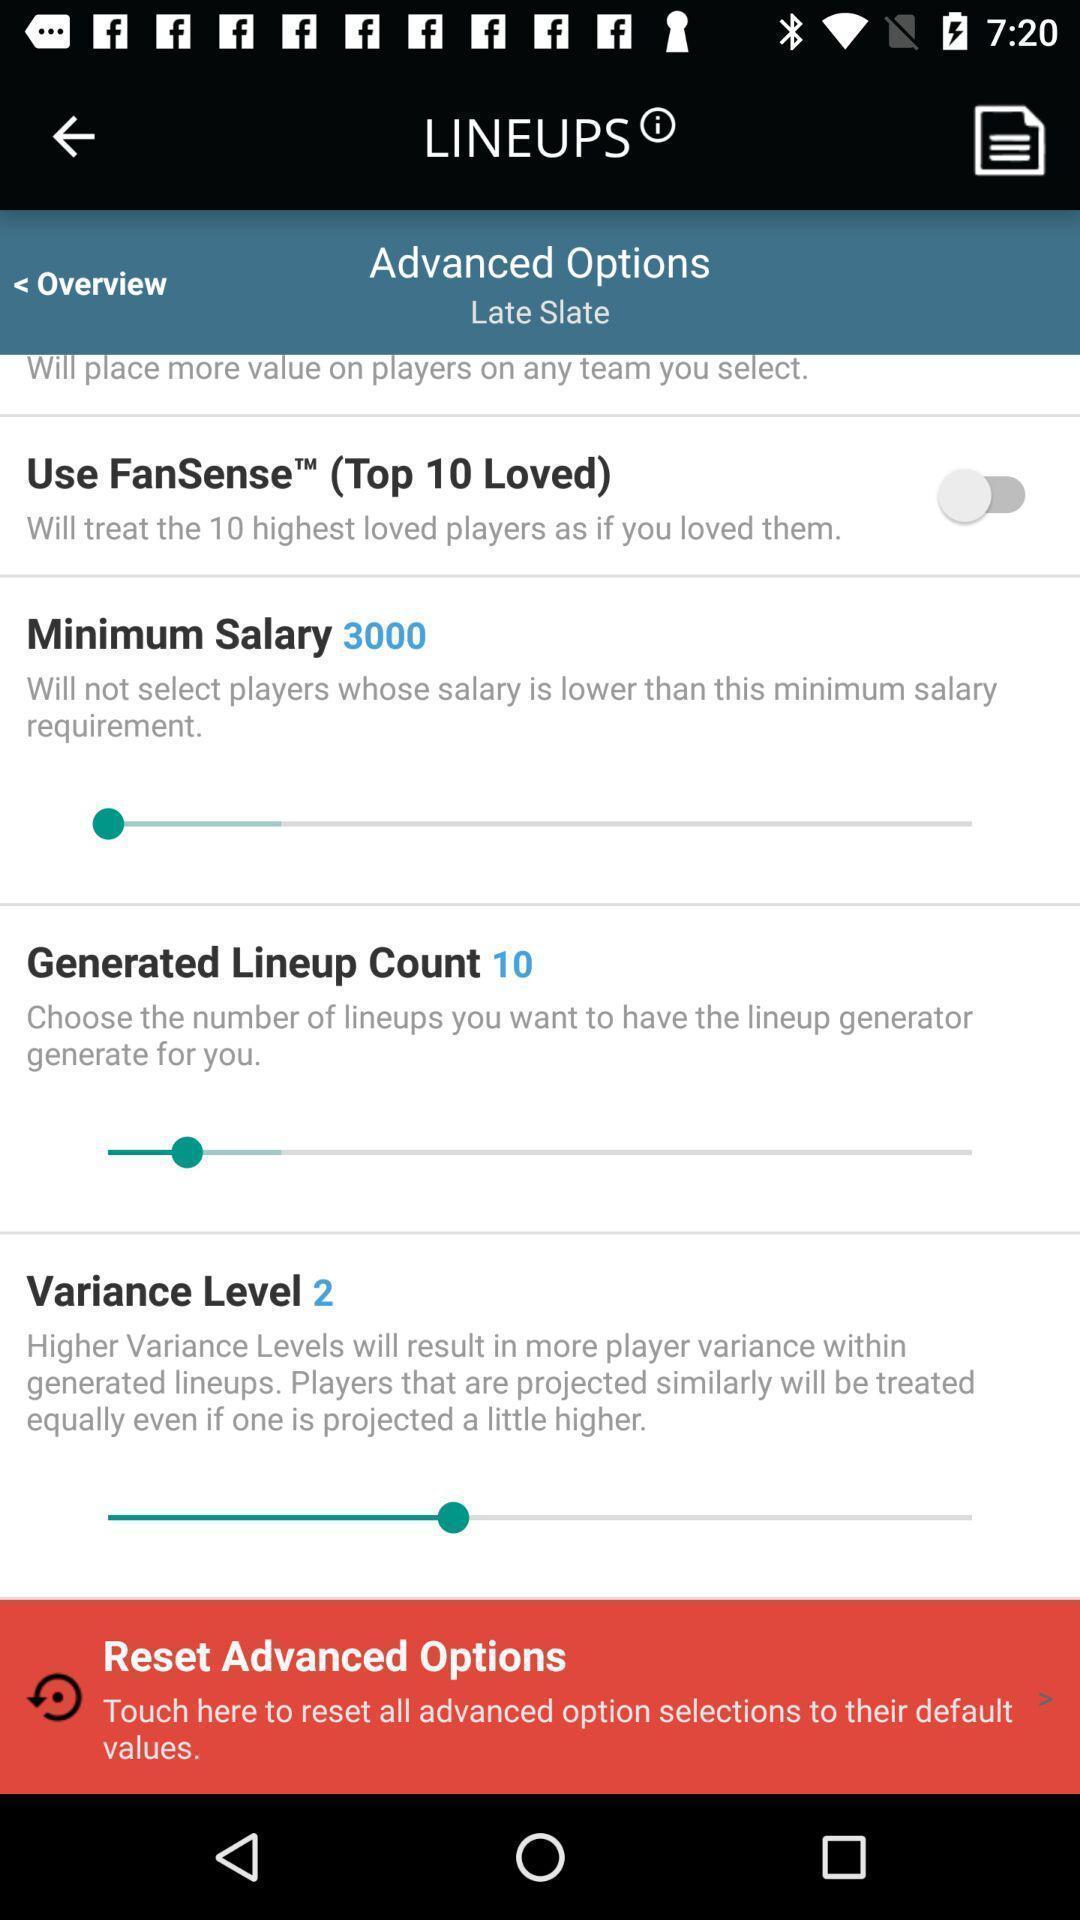Provide a textual representation of this image. Window displaying a sports app. 